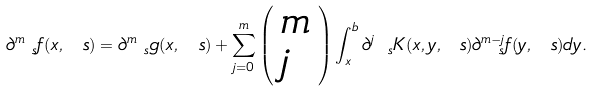Convert formula to latex. <formula><loc_0><loc_0><loc_500><loc_500>\partial _ { \ s } ^ { m } f ( x , \ s ) = \partial _ { \ s } ^ { m } g ( x , \ s ) + \sum _ { j = 0 } ^ { m } \left ( \begin{array} { l l } m \\ j \end{array} \right ) \int _ { x } ^ { b } \partial _ { \ s } ^ { j } K ( x , y , \ s ) \partial _ { \ s } ^ { m - j } f ( y , \ s ) d y .</formula> 